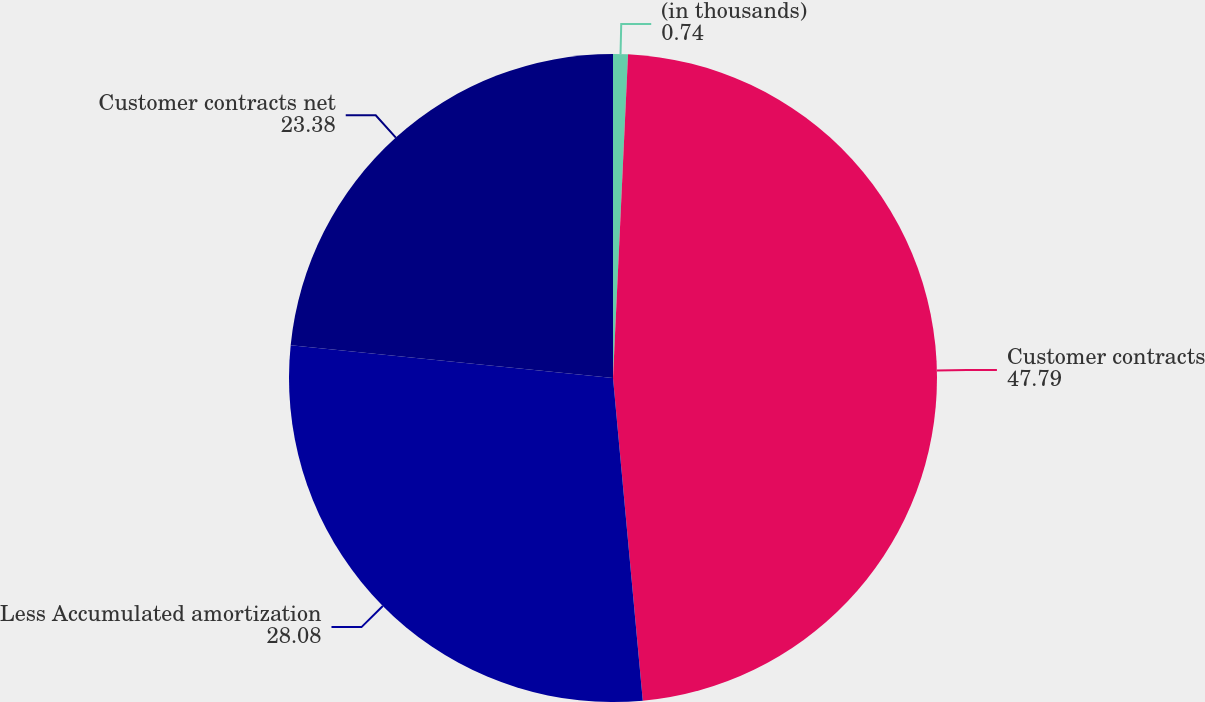Convert chart to OTSL. <chart><loc_0><loc_0><loc_500><loc_500><pie_chart><fcel>(in thousands)<fcel>Customer contracts<fcel>Less Accumulated amortization<fcel>Customer contracts net<nl><fcel>0.74%<fcel>47.79%<fcel>28.08%<fcel>23.38%<nl></chart> 